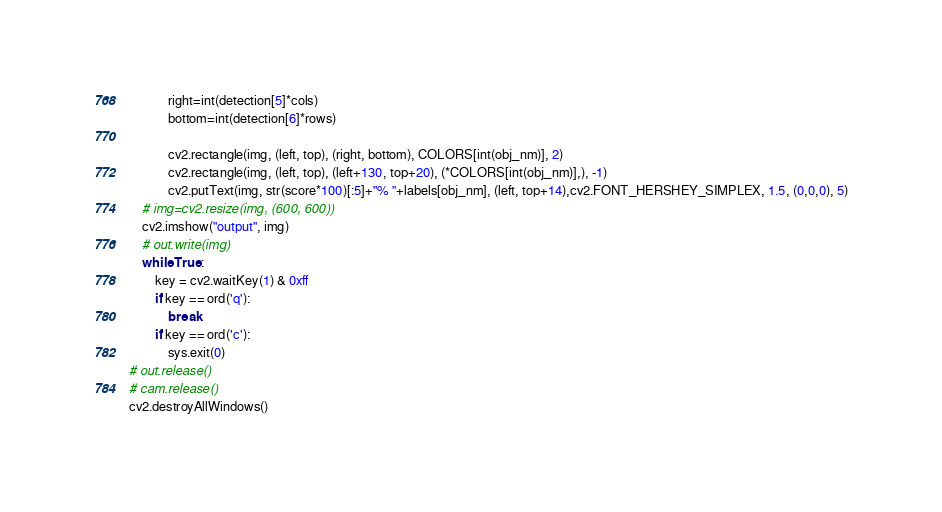<code> <loc_0><loc_0><loc_500><loc_500><_Python_>			right=int(detection[5]*cols)
			bottom=int(detection[6]*rows)

			cv2.rectangle(img, (left, top), (right, bottom), COLORS[int(obj_nm)], 2)
			cv2.rectangle(img, (left, top), (left+130, top+20), (*COLORS[int(obj_nm)],), -1)
			cv2.putText(img, str(score*100)[:5]+"% "+labels[obj_nm], (left, top+14),cv2.FONT_HERSHEY_SIMPLEX, 1.5, (0,0,0), 5)
	# img=cv2.resize(img, (600, 600))
	cv2.imshow("output", img)
	# out.write(img)
	while True:
		key = cv2.waitKey(1) & 0xff
		if key == ord('q'):
			break
		if key == ord('c'):
			sys.exit(0)
# out.release()
# cam.release()
cv2.destroyAllWindows()</code> 